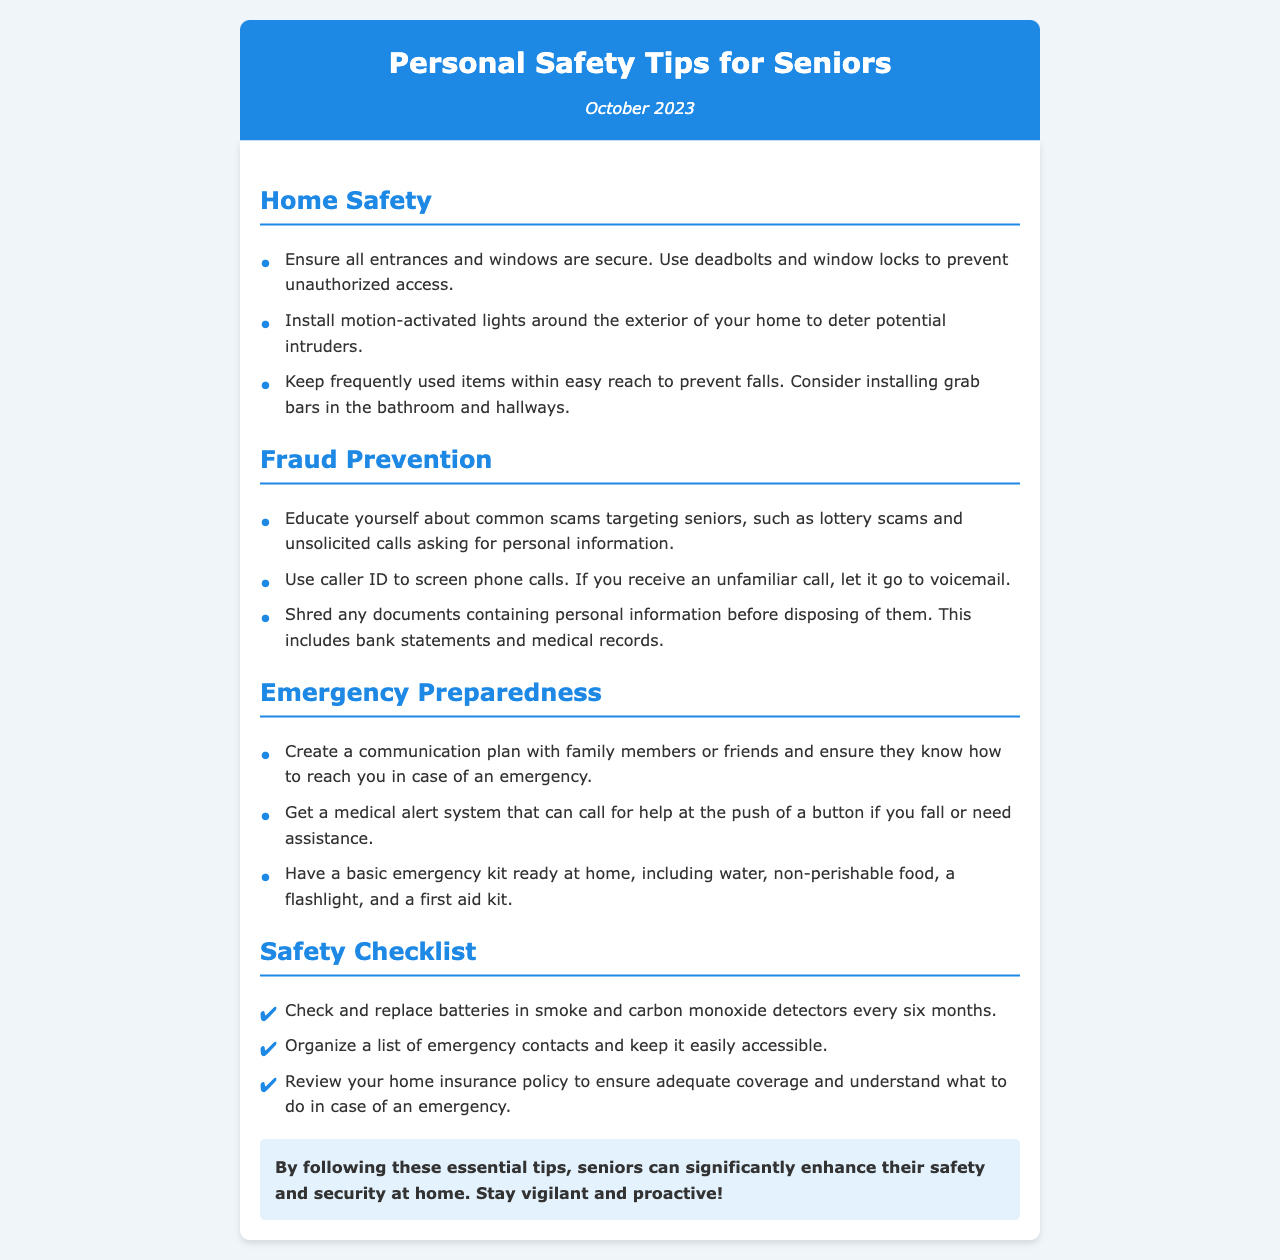What is the title of the newsletter? The title of the newsletter is found in the header section at the top of the document.
Answer: Personal Safety Tips for Seniors When was the newsletter published? The publication date is located in the date line directly beneath the title in the header.
Answer: October 2023 What system can be used to call for help if assistance is needed? This information is mentioned in the Emergency Preparedness section of the document.
Answer: Medical alert system What should you do with documents containing personal information? This is detailed in the Fraud Prevention section, specifying actions to take before disposing of such documents.
Answer: Shred How often should batteries in smoke detectors be checked? The frequency of checking batteries in smoke detectors is provided in the Safety Checklist section.
Answer: Every six months What is recommended to install around the exterior of the home? This recommendation is found in the Home Safety section, describing a security measure against intruders.
Answer: Motion-activated lights What should be included in a basic emergency kit? The Emergency Preparedness section outlines essential items to prepare for emergencies.
Answer: Water, non-perishable food, flashlight, first aid kit What type of scams should seniors educate themselves about? This is specified in the Fraud Prevention section, listing the types of scams targeting seniors.
Answer: Lottery scams What is the purpose of organizing a list of emergency contacts? The document explains the importance of having readily accessible emergency contacts in the Safety Checklist section.
Answer: Easily accessible in case of emergencies 